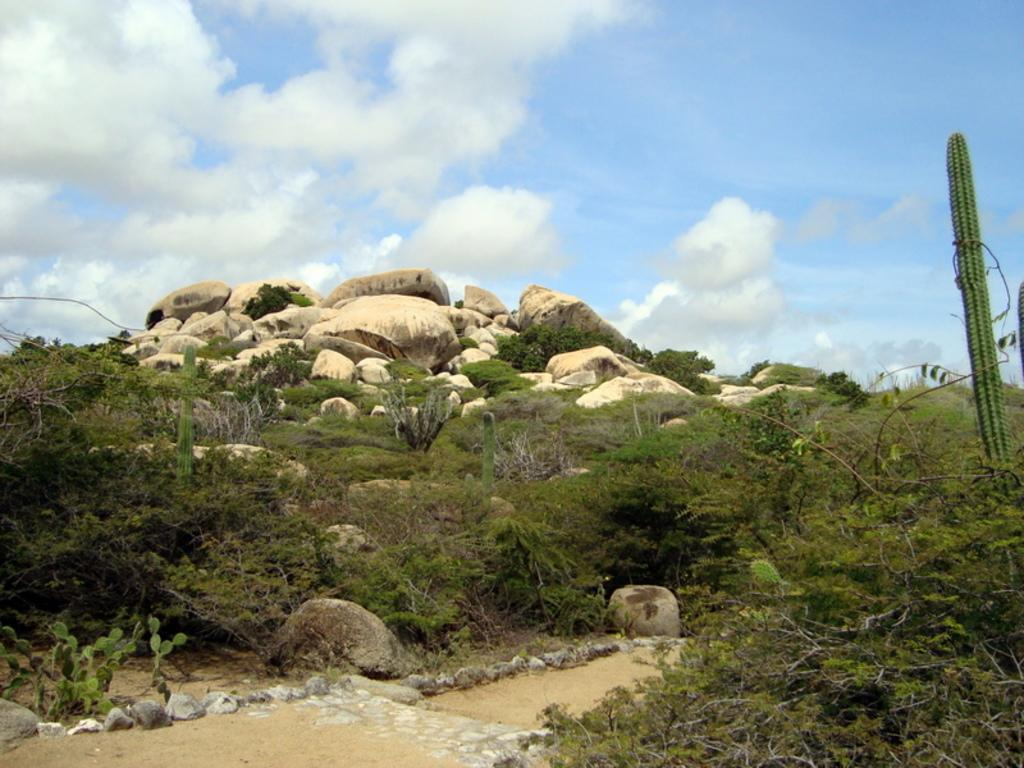What type of vegetation can be seen in the image? There are trees in the image. What other natural elements are present in the image? There are stones and sand visible in the image. What is the color of the sky in the image? The sky is blue and white in color. How many leaves can be seen on the jellyfish in the image? There are no jellyfish present in the image, and therefore no leaves can be seen on them. 